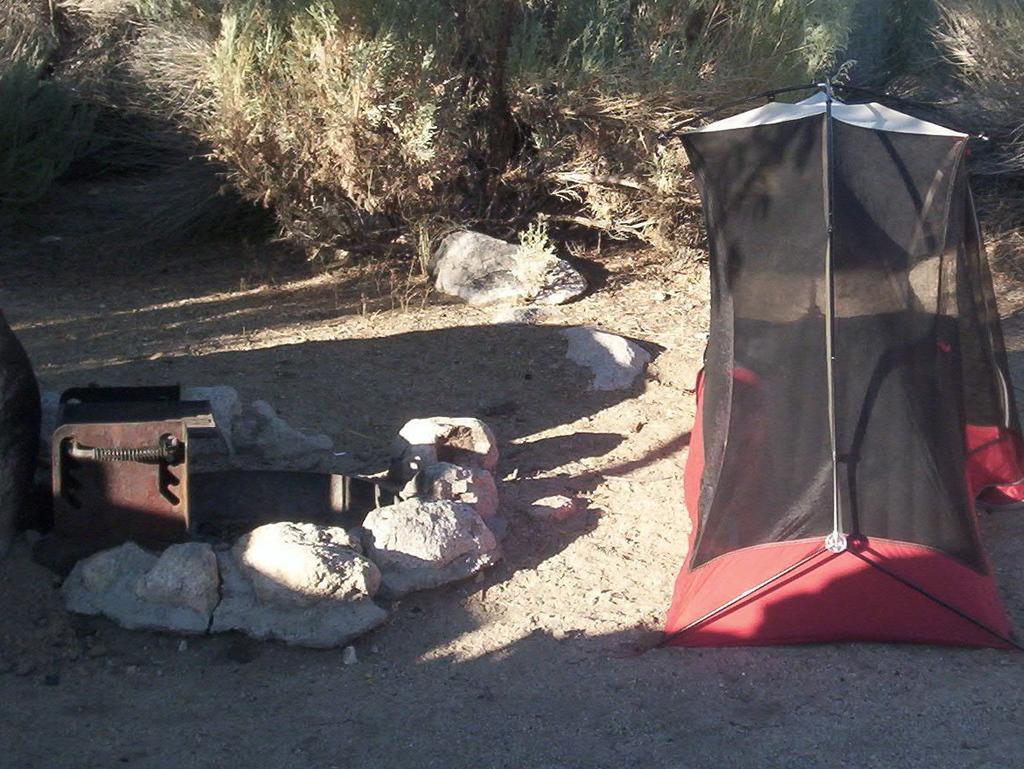In one or two sentences, can you explain what this image depicts? In this image we can see a tent, stones, shredded leaves, shrubs and lawn straw. 